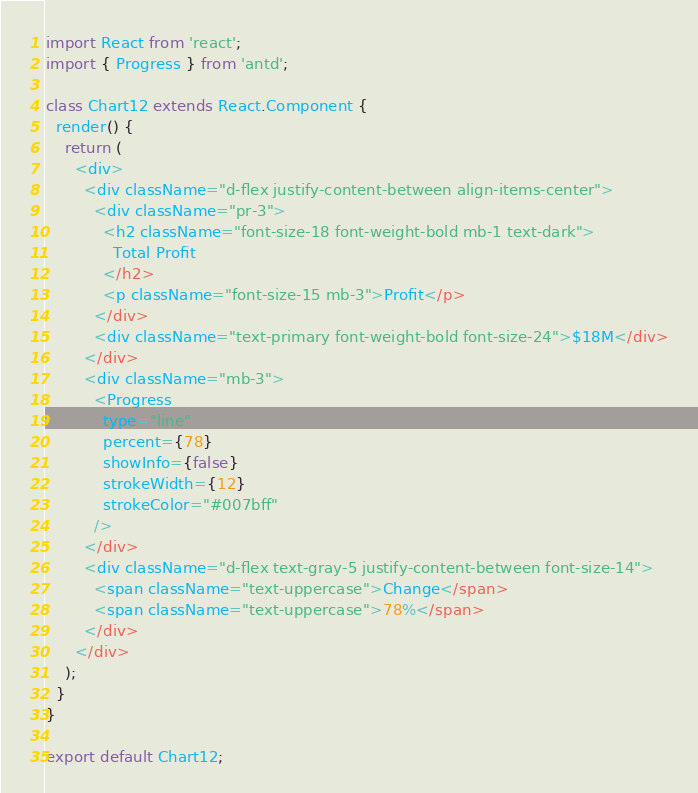<code> <loc_0><loc_0><loc_500><loc_500><_JavaScript_>import React from 'react';
import { Progress } from 'antd';

class Chart12 extends React.Component {
  render() {
    return (
      <div>
        <div className="d-flex justify-content-between align-items-center">
          <div className="pr-3">
            <h2 className="font-size-18 font-weight-bold mb-1 text-dark">
              Total Profit
            </h2>
            <p className="font-size-15 mb-3">Profit</p>
          </div>
          <div className="text-primary font-weight-bold font-size-24">$18M</div>
        </div>
        <div className="mb-3">
          <Progress
            type="line"
            percent={78}
            showInfo={false}
            strokeWidth={12}
            strokeColor="#007bff"
          />
        </div>
        <div className="d-flex text-gray-5 justify-content-between font-size-14">
          <span className="text-uppercase">Change</span>
          <span className="text-uppercase">78%</span>
        </div>
      </div>
    );
  }
}

export default Chart12;
</code> 